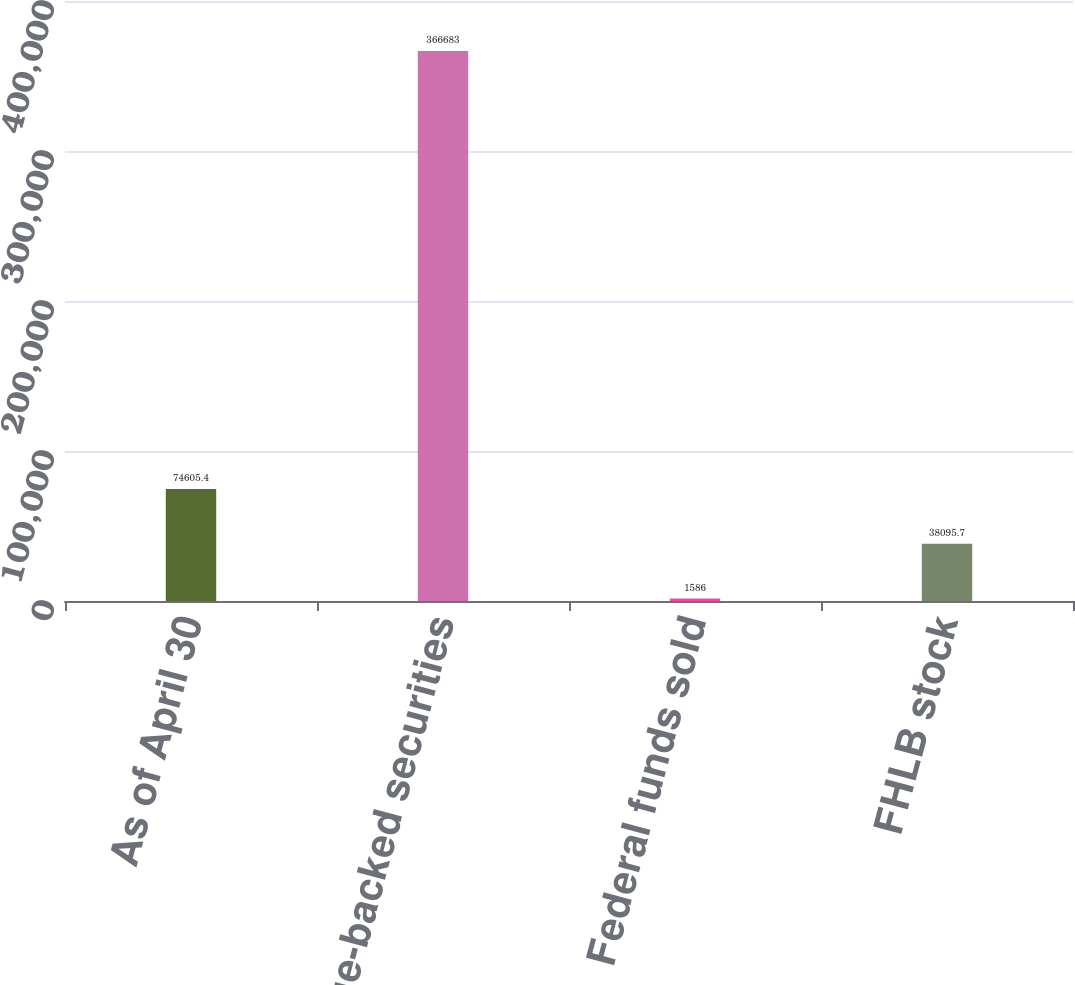Convert chart. <chart><loc_0><loc_0><loc_500><loc_500><bar_chart><fcel>As of April 30<fcel>Mortgage-backed securities<fcel>Federal funds sold<fcel>FHLB stock<nl><fcel>74605.4<fcel>366683<fcel>1586<fcel>38095.7<nl></chart> 